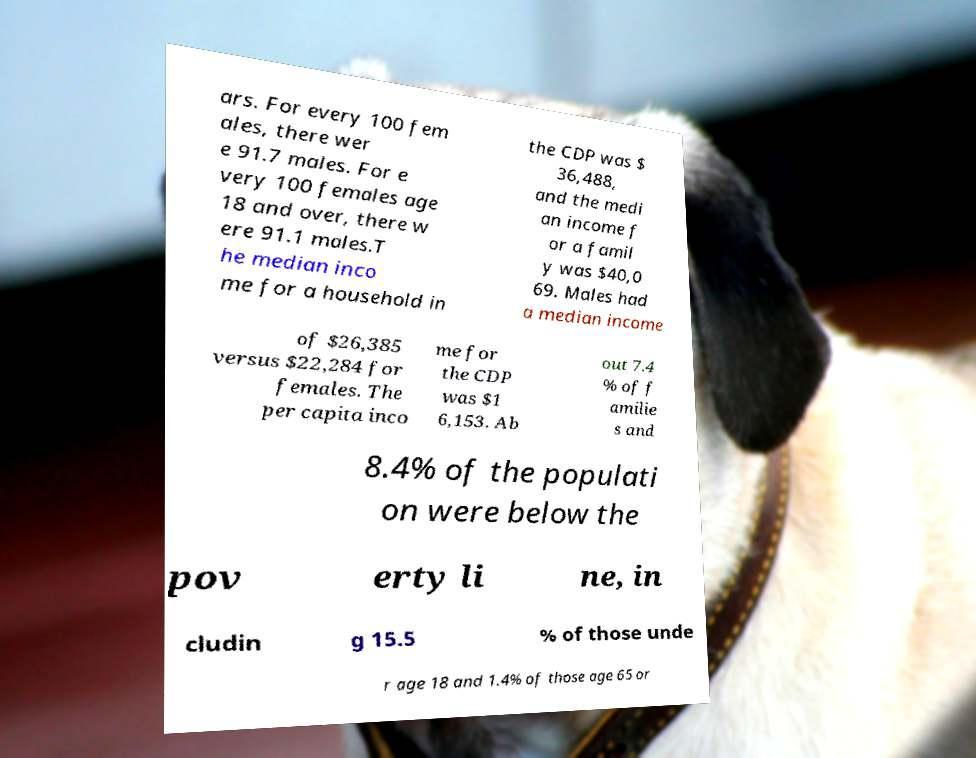I need the written content from this picture converted into text. Can you do that? ars. For every 100 fem ales, there wer e 91.7 males. For e very 100 females age 18 and over, there w ere 91.1 males.T he median inco me for a household in the CDP was $ 36,488, and the medi an income f or a famil y was $40,0 69. Males had a median income of $26,385 versus $22,284 for females. The per capita inco me for the CDP was $1 6,153. Ab out 7.4 % of f amilie s and 8.4% of the populati on were below the pov erty li ne, in cludin g 15.5 % of those unde r age 18 and 1.4% of those age 65 or 